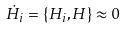Convert formula to latex. <formula><loc_0><loc_0><loc_500><loc_500>\dot { H } _ { i } = \{ H _ { i } , H \} \approx 0</formula> 